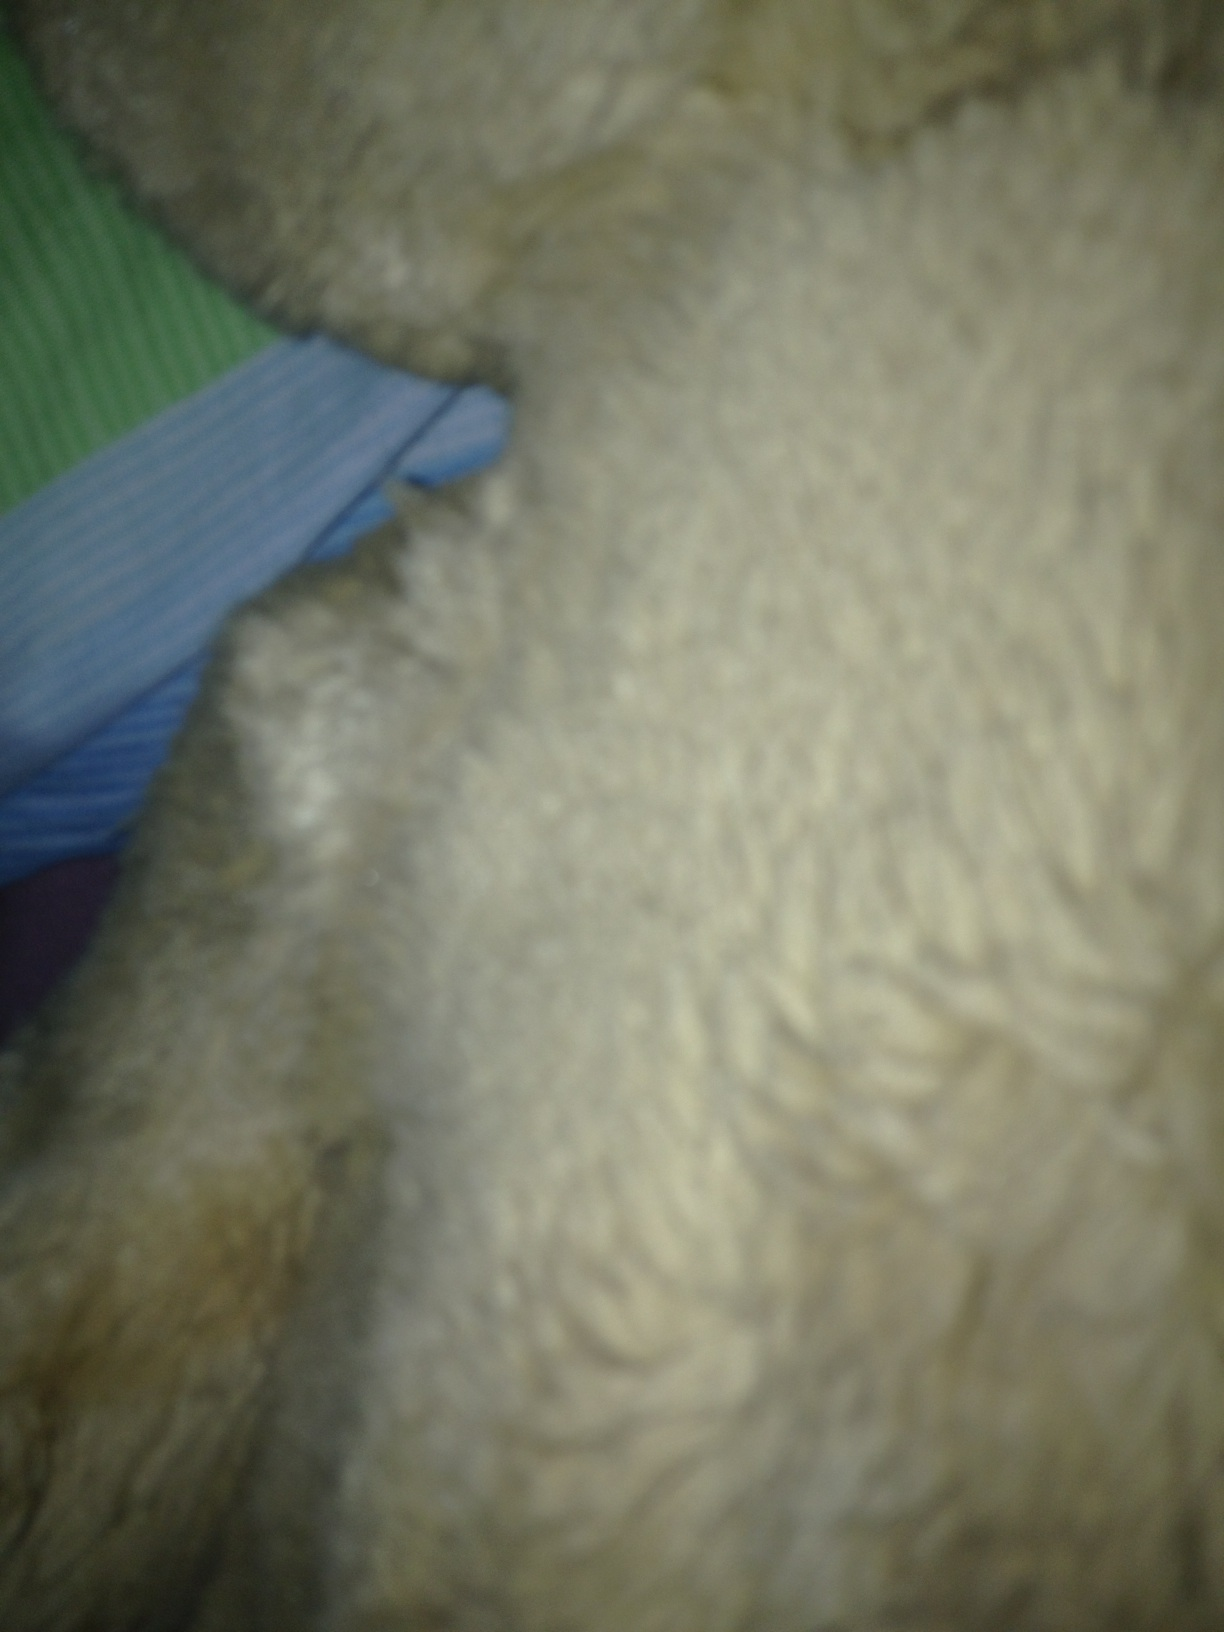Write a poem inspired by the image. In the depths of velvet night,
A creature fuzzy, out of sight,
With fur as soft as evening’s breath,
A touch that quiets, calms, and bless.
The moonlight dances, shadows play,
On surfaces where dreamers lay.
Amid the textures, stories blend,
Of comfort found, and hearts to mend.
In quiet slumber's sweet embrace,
Furry warmth and gentle grace,
Remind us in the darkest eve,
Softness speaks for those who grieve. 